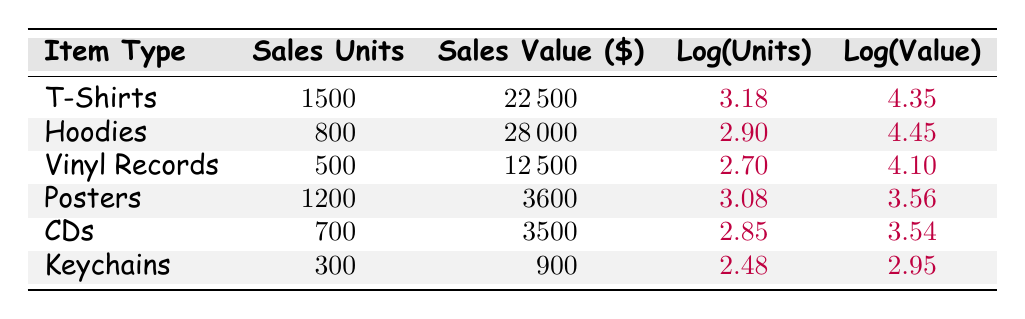What is the sales value of T-Shirts? The table shows that the sales value for T-Shirts is listed under the "Sales Value" column, which is \$22,500.
Answer: 22,500 How many units of Hoodies were sold? The "Sales Units" column indicates that 800 units of Hoodies were sold.
Answer: 800 Which item type had the highest sales value? By comparing the "Sales Value" column, Hoodies have the highest sales value at \$28,000.
Answer: Hoodies What is the total sales value of all items combined? To find the total sales value, add up all the values: 22,500 + 28,000 + 12,500 + 3,600 + 3,500 + 900 = 70,000.
Answer: 70,000 Is the sales value of Posters greater than that of CDs? The sales value of Posters is \$3,600, while that of CDs is \$3,500. Since 3,600 is greater than 3,500, the statement is true.
Answer: Yes What is the average sales units sold across all item types? To calculate the average, sum the sales units: 1500 + 800 + 500 + 1200 + 700 + 300 = 4000, then divide by the number of item types (6): 4000 / 6 ≈ 666.67.
Answer: 666.67 Which item sold more units: T-Shirts or Posters? T-Shirts sold 1500 units while Posters sold 1200 units. Since 1500 is greater than 1200, T-Shirts sold more.
Answer: T-Shirts What is the difference in sales value between Hoodies and Vinyl Records? The sales value for Hoodies is \$28,000 and for Vinyl Records it is \$12,500. The difference is 28,000 - 12,500 = 15,500.
Answer: 15,500 Are Keychains the least sold item by units? Keychains sold 300 units, while the other items sold more units: T-Shirts (1500), Hoodies (800), Vinyl Records (500), Posters (1200), and CDs (700). Therefore, Keychains are indeed the least sold item.
Answer: Yes 